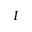Convert formula to latex. <formula><loc_0><loc_0><loc_500><loc_500>I</formula> 